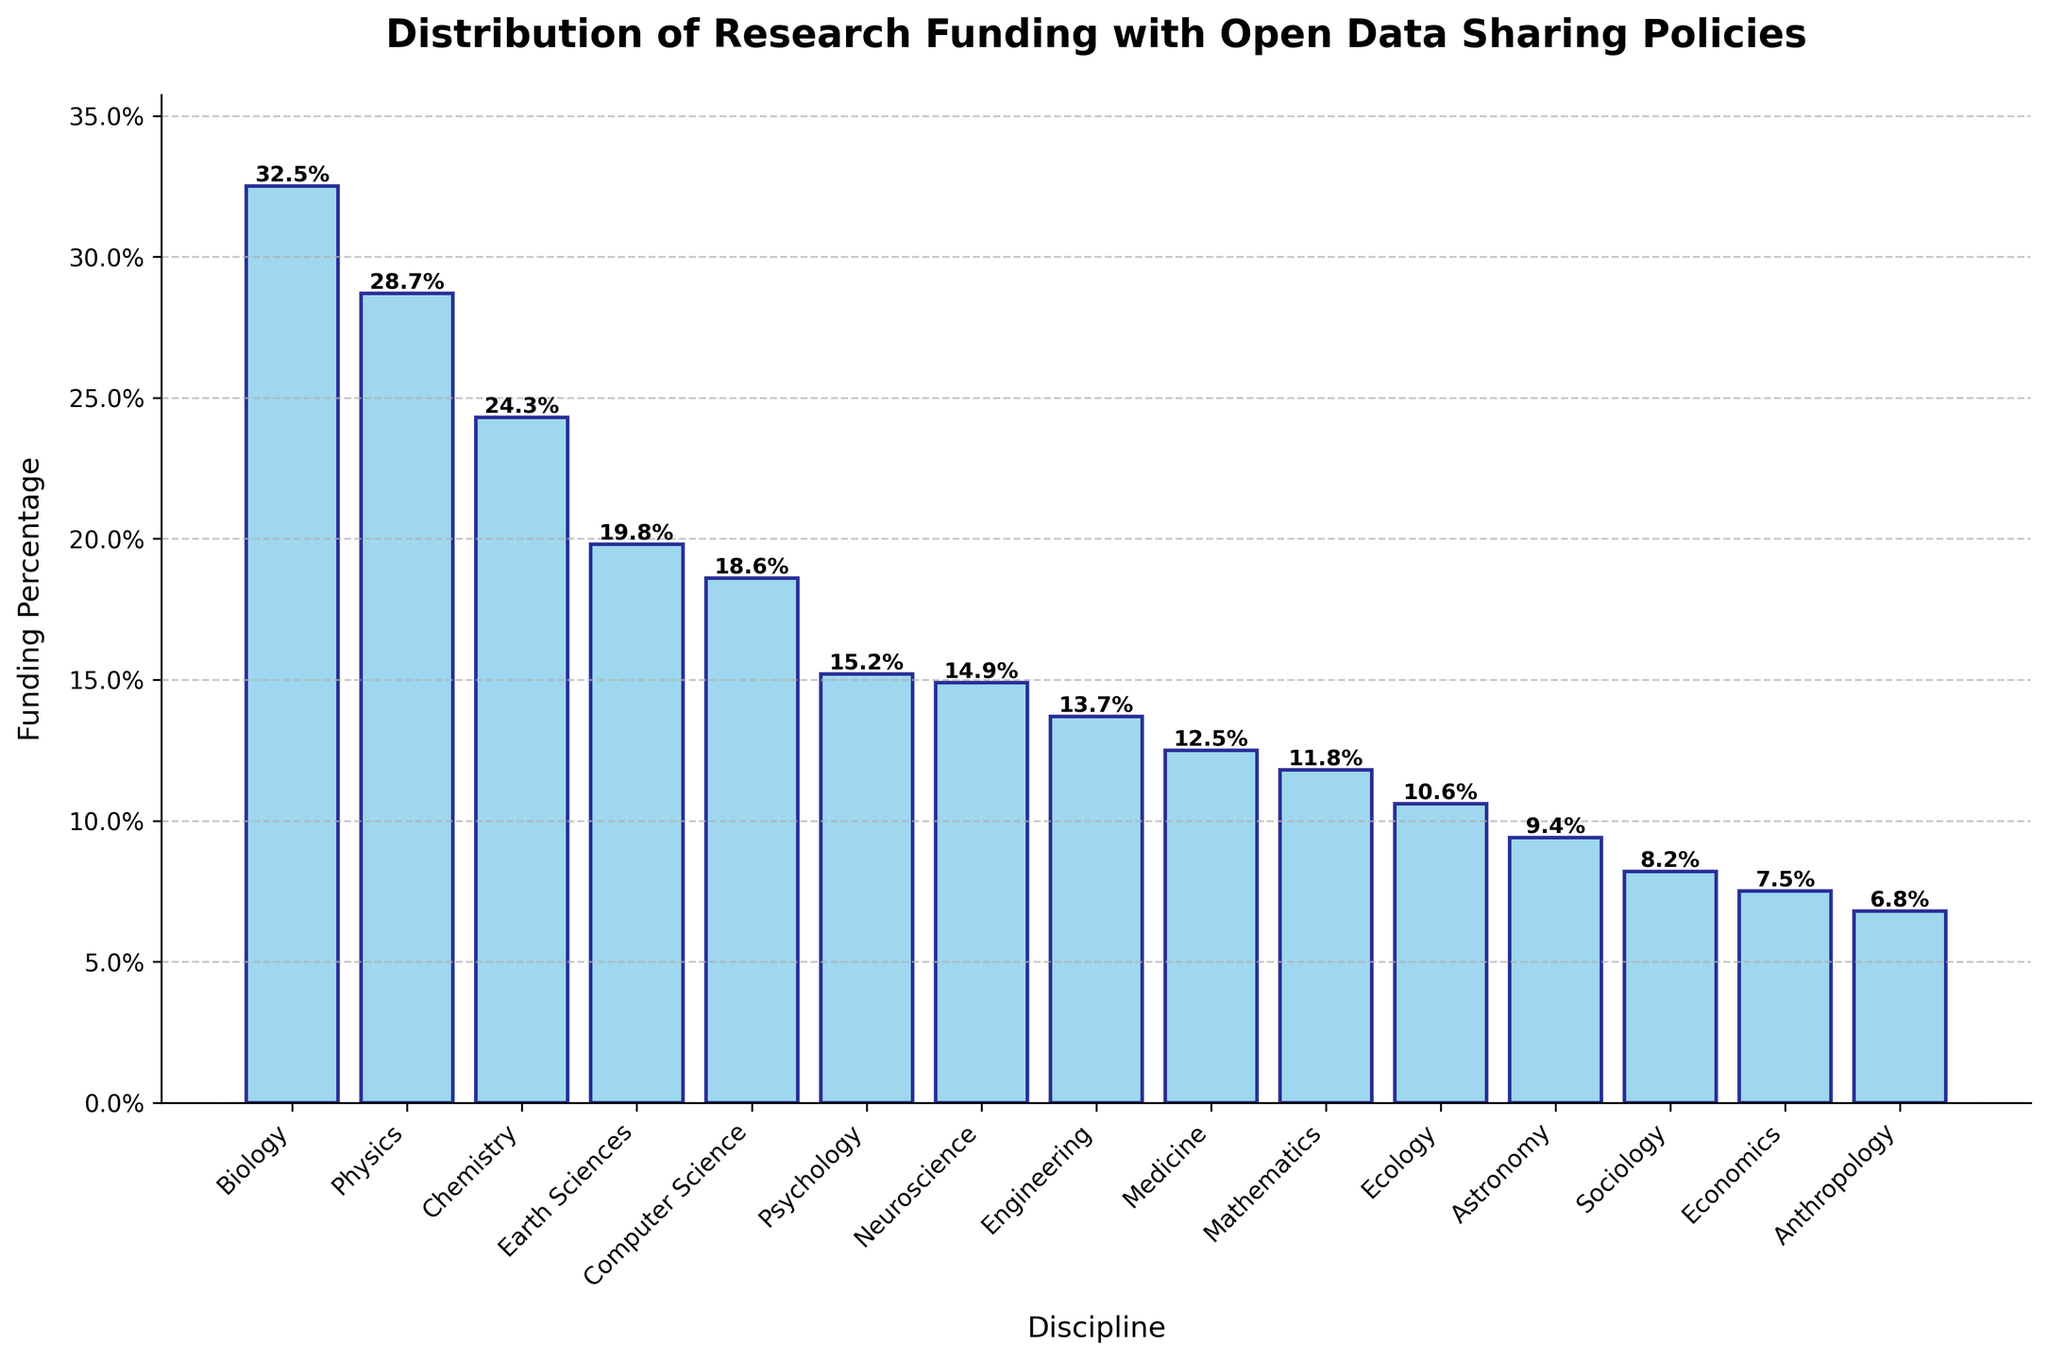Which discipline receives the highest percentage of research funding? The bar labeled "Biology" has the tallest height compared to the others.
Answer: Biology Which discipline receives the least percentage of research funding? The bar labeled "Anthropology" is the shortest among all.
Answer: Anthropology How much more funding percentage does Biology have compared to Sociology? The funding for Biology is 32.5%, and for Sociology, it is 8.2%. Subtracting these gives 32.5% - 8.2%.
Answer: 24.3% Rank the top three disciplines receiving the highest research funding. By comparing the heights of the bars, Biology, Physics, and Chemistry have the three highest bars in descending order.
Answer: Biology, Physics, Chemistry What is the total percentage of research funding dedicated to disciplines with a funding percentage above 20%? The disciplines with percentages above 20% are Biology (32.5%), Physics (28.7%), and Chemistry (24.3%). Adding these gives 32.5 + 28.7 + 24.3.
Answer: 85.5% How much more funding percentage does Computer Science have compared to Medicine? The funding for Computer Science is 18.6%, and for Medicine, it is 12.5%. Subtracting these gives 18.6% - 12.5%.
Answer: 6.1% Which disciplines have a funding percentage below 15%? The bars for Psychology (15.2%), Neuroscience (14.9%), Engineering (13.7%), Medicine (12.5%), Mathematics (11.8%), Ecology (10.6%), Astronomy (9.4%), Sociology (8.2%), Economics (7.5%), and Anthropology (6.8%) are below 15%.
Answer: Psychology, Neuroscience, Engineering, Medicine, Mathematics, Ecology, Astronomy, Sociology, Economics, Anthropology What is the difference in funding percentage between Physics and Earth Sciences? The funding for Physics is 28.7%, and for Earth Sciences, it is 19.8%. Subtracting these gives 28.7% - 19.8%.
Answer: 8.9% Which discipline has a funding percentage closest to the average funding percentage? The average percentage is the total of all percentages divided by the number of disciplines. Sum all percentages and divide by 15 disciplines to get around 16.3%. The closest to this value is Psychology with 15.2%.
Answer: Psychology 